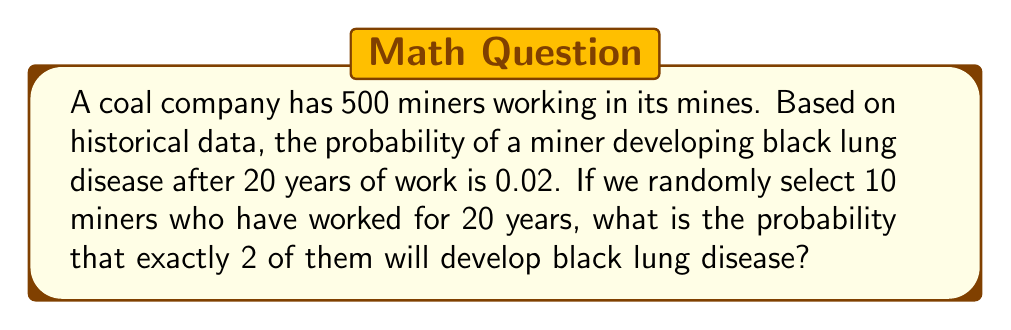What is the answer to this math problem? To solve this problem, we'll use the binomial probability formula:

$$P(X = k) = \binom{n}{k} p^k (1-p)^{n-k}$$

Where:
$n$ = number of trials (miners selected) = 10
$k$ = number of successes (miners with black lung) = 2
$p$ = probability of success (developing black lung) = 0.02

Step 1: Calculate the binomial coefficient
$$\binom{10}{2} = \frac{10!}{2!(10-2)!} = \frac{10!}{2!8!} = 45$$

Step 2: Calculate $p^k$
$$0.02^2 = 0.0004$$

Step 3: Calculate $(1-p)^{n-k}$
$$(1-0.02)^{10-2} = 0.98^8 \approx 0.8508$$

Step 4: Multiply all parts together
$$45 \times 0.0004 \times 0.8508 \approx 0.0153$$

Therefore, the probability of exactly 2 out of 10 randomly selected miners developing black lung disease is approximately 0.0153 or 1.53%.
Answer: 0.0153 